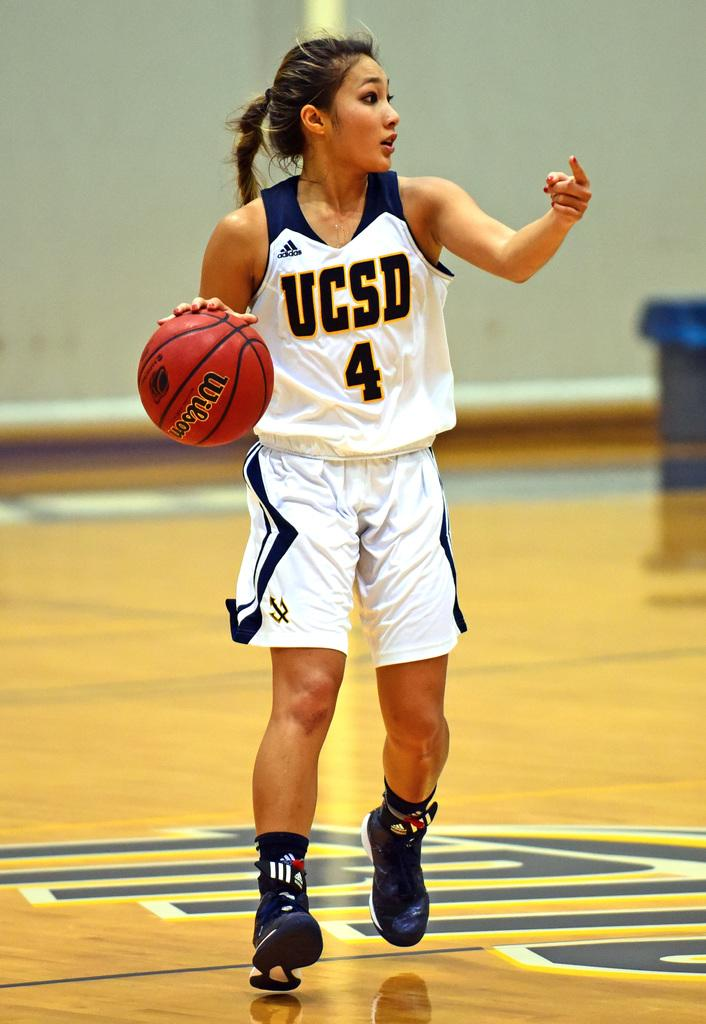Who is present in the image? There is a woman in the image. What is the woman doing in the image? The woman is standing on the floor and holding a ball in her hands. What can be seen behind the woman in the image? There is a wall visible in the image. How many kittens are playing on the territory in the image? There are no kittens or territory present in the image. 